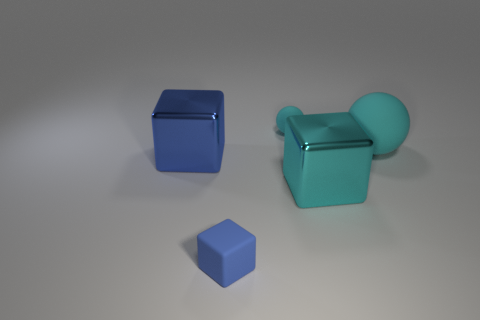Is the shape of the large cyan matte thing the same as the blue shiny thing to the left of the big cyan rubber object?
Give a very brief answer. No. Is the number of big cyan rubber things that are in front of the big blue metallic thing less than the number of small matte cubes that are behind the tiny blue thing?
Ensure brevity in your answer.  No. Is the small cyan rubber thing the same shape as the large cyan rubber thing?
Your answer should be compact. Yes. What is the size of the cyan cube?
Make the answer very short. Large. What color is the rubber object that is both on the right side of the small blue cube and in front of the small cyan sphere?
Make the answer very short. Cyan. Are there more metal things than objects?
Your answer should be very brief. No. How many things are either small blue shiny cylinders or cyan objects that are to the left of the large cyan ball?
Keep it short and to the point. 2. Does the cyan metallic thing have the same size as the blue matte block?
Provide a succinct answer. No. Are there any balls on the left side of the large cyan rubber sphere?
Ensure brevity in your answer.  Yes. There is a rubber object that is on the right side of the blue matte thing and on the left side of the large cyan matte ball; how big is it?
Make the answer very short. Small. 